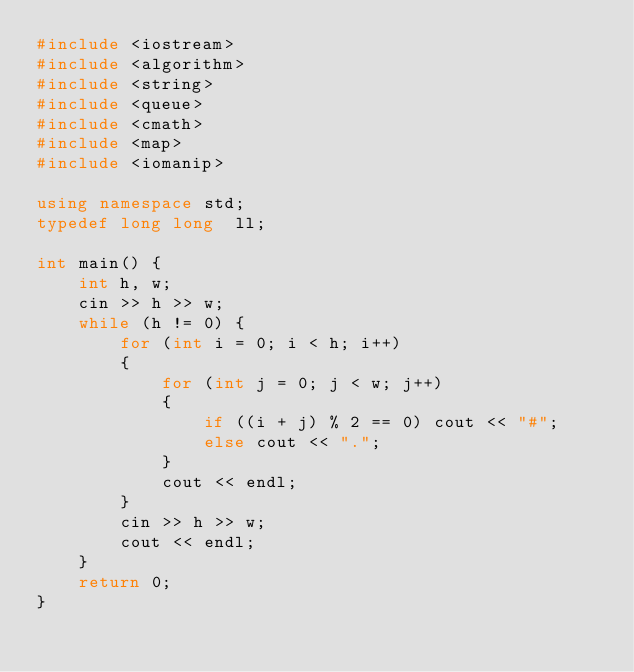Convert code to text. <code><loc_0><loc_0><loc_500><loc_500><_C++_>#include <iostream>
#include <algorithm>
#include <string>
#include <queue>
#include <cmath>
#include <map>
#include <iomanip>

using namespace std;
typedef long long  ll;

int main() {
	int h, w;
	cin >> h >> w;
	while (h != 0) {
		for (int i = 0; i < h; i++)
		{
			for (int j = 0; j < w; j++)
			{
				if ((i + j) % 2 == 0) cout << "#";
				else cout << ".";
			}
			cout << endl;
		}
		cin >> h >> w;
		cout << endl;
	}
	return 0;
}
</code> 